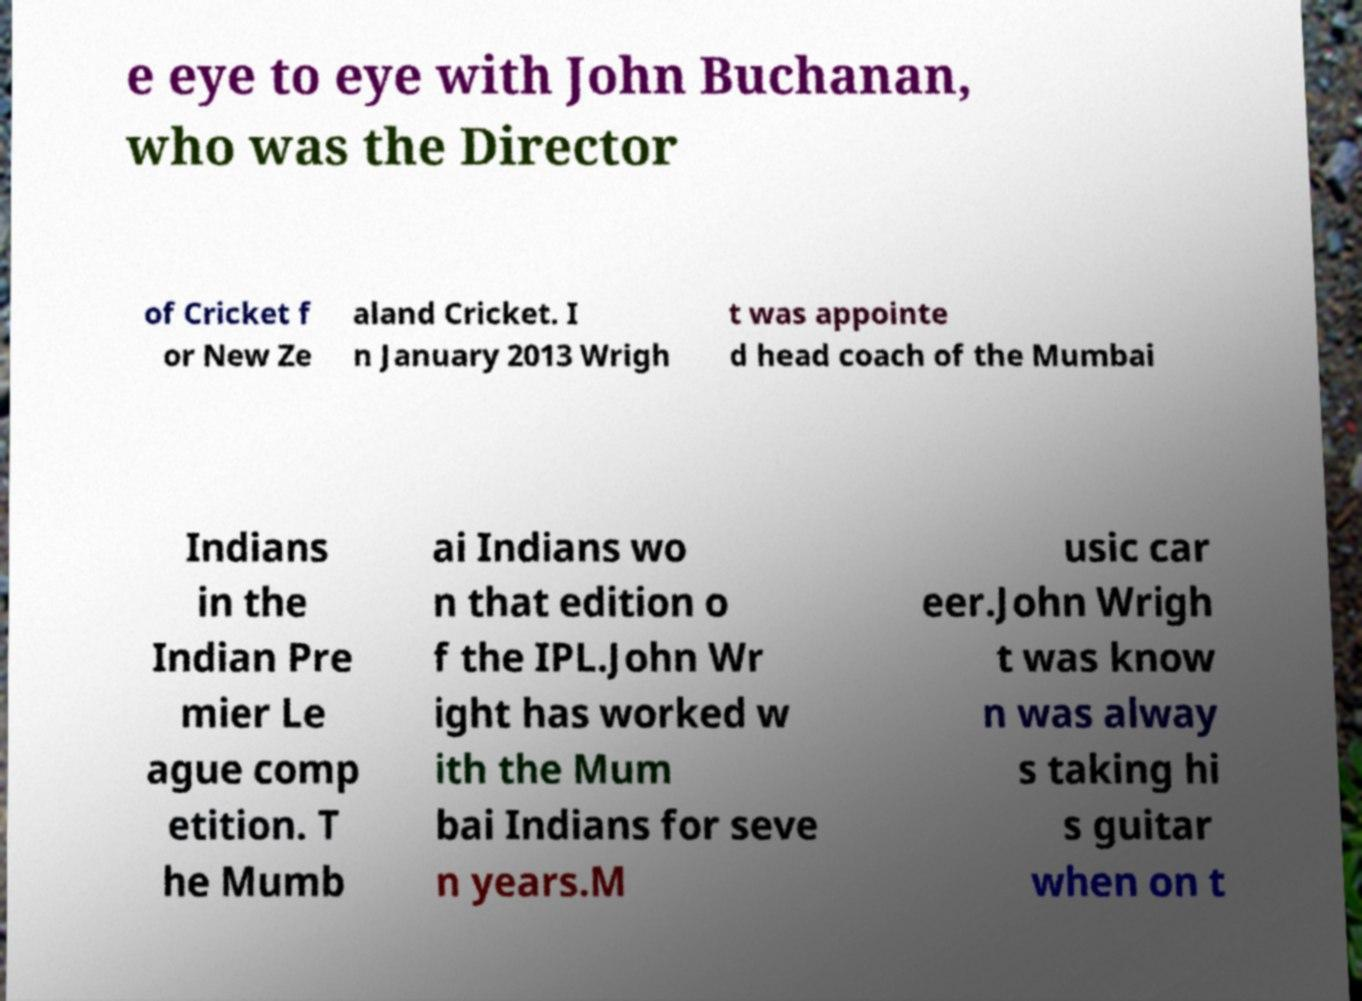What messages or text are displayed in this image? I need them in a readable, typed format. e eye to eye with John Buchanan, who was the Director of Cricket f or New Ze aland Cricket. I n January 2013 Wrigh t was appointe d head coach of the Mumbai Indians in the Indian Pre mier Le ague comp etition. T he Mumb ai Indians wo n that edition o f the IPL.John Wr ight has worked w ith the Mum bai Indians for seve n years.M usic car eer.John Wrigh t was know n was alway s taking hi s guitar when on t 